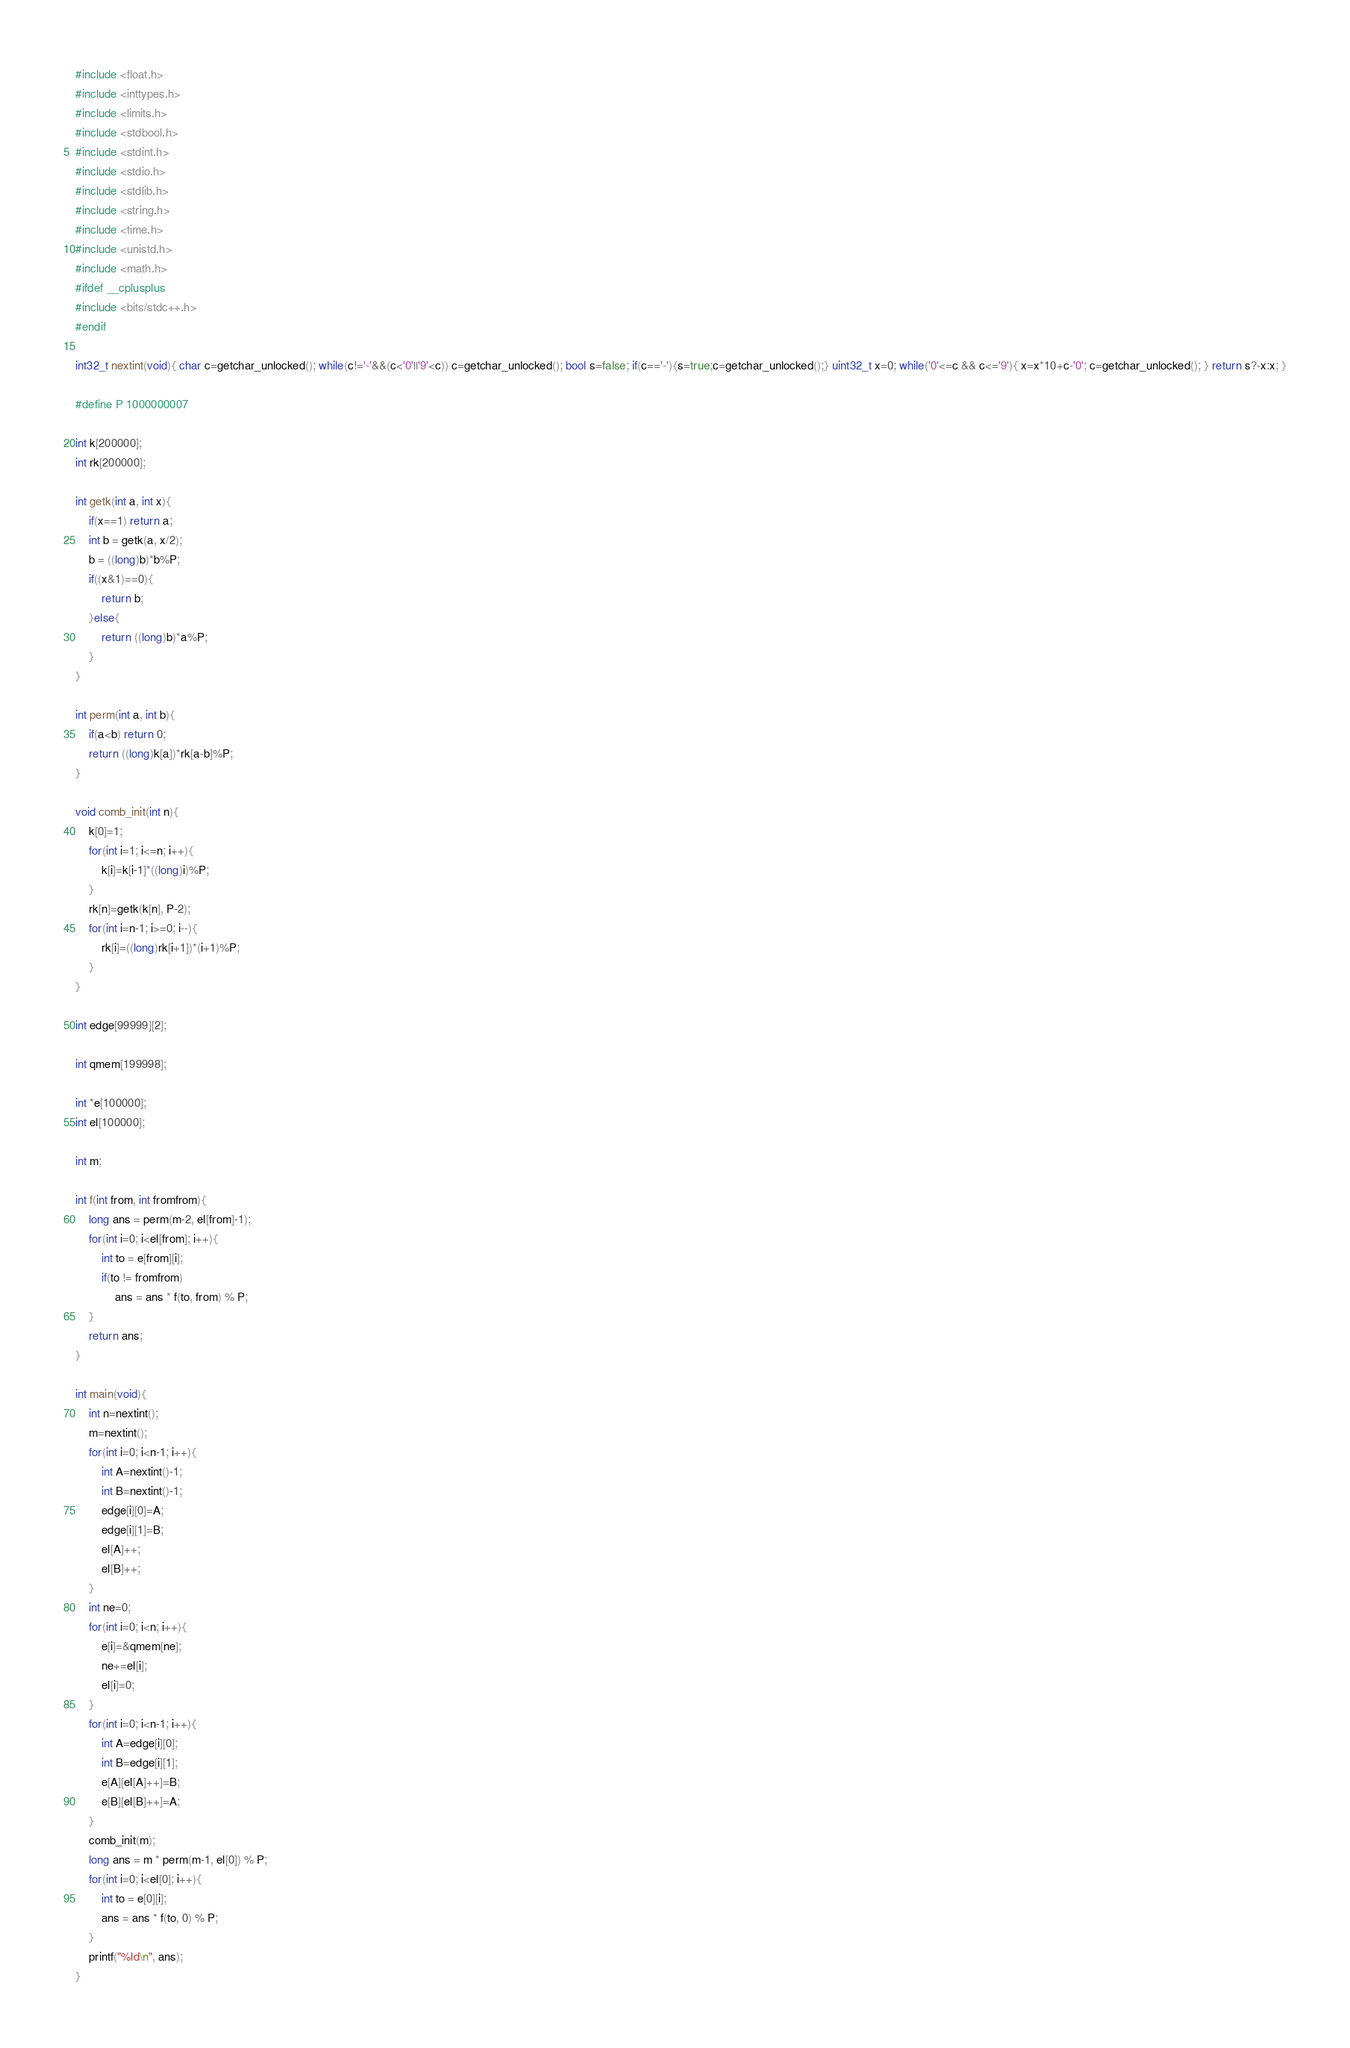Convert code to text. <code><loc_0><loc_0><loc_500><loc_500><_C_>#include <float.h>
#include <inttypes.h>
#include <limits.h>
#include <stdbool.h>
#include <stdint.h>
#include <stdio.h>
#include <stdlib.h>
#include <string.h>
#include <time.h>
#include <unistd.h>
#include <math.h>
#ifdef __cplusplus
#include <bits/stdc++.h>
#endif

int32_t nextint(void){ char c=getchar_unlocked(); while(c!='-'&&(c<'0'||'9'<c)) c=getchar_unlocked(); bool s=false; if(c=='-'){s=true;c=getchar_unlocked();} uint32_t x=0; while('0'<=c && c<='9'){ x=x*10+c-'0'; c=getchar_unlocked(); } return s?-x:x; }

#define P 1000000007

int k[200000];
int rk[200000];

int getk(int a, int x){
	if(x==1) return a;
	int b = getk(a, x/2);
	b = ((long)b)*b%P;
	if((x&1)==0){
		return b;
	}else{
		return ((long)b)*a%P;
	}
}

int perm(int a, int b){
	if(a<b) return 0;
	return ((long)k[a])*rk[a-b]%P;
}

void comb_init(int n){
	k[0]=1;
	for(int i=1; i<=n; i++){
		k[i]=k[i-1]*((long)i)%P;
	}	
	rk[n]=getk(k[n], P-2);
	for(int i=n-1; i>=0; i--){
		rk[i]=((long)rk[i+1])*(i+1)%P;
	}
}

int edge[99999][2];

int qmem[199998];

int *e[100000];
int el[100000];

int m;

int f(int from, int fromfrom){
	long ans = perm(m-2, el[from]-1);
	for(int i=0; i<el[from]; i++){
		int to = e[from][i];
		if(to != fromfrom)
			ans = ans * f(to, from) % P;
	}
	return ans;
}

int main(void){
	int n=nextint();
	m=nextint();
	for(int i=0; i<n-1; i++){
		int A=nextint()-1;
		int B=nextint()-1;
		edge[i][0]=A;
		edge[i][1]=B;
		el[A]++;
		el[B]++;
	}
	int ne=0;
	for(int i=0; i<n; i++){
		e[i]=&qmem[ne];
		ne+=el[i];
		el[i]=0;
	}
	for(int i=0; i<n-1; i++){
		int A=edge[i][0];
		int B=edge[i][1];
		e[A][el[A]++]=B;
		e[B][el[B]++]=A;
	}
	comb_init(m);
	long ans = m * perm(m-1, el[0]) % P;
	for(int i=0; i<el[0]; i++){
		int to = e[0][i];
		ans = ans * f(to, 0) % P;
	}
	printf("%ld\n", ans);
}
</code> 